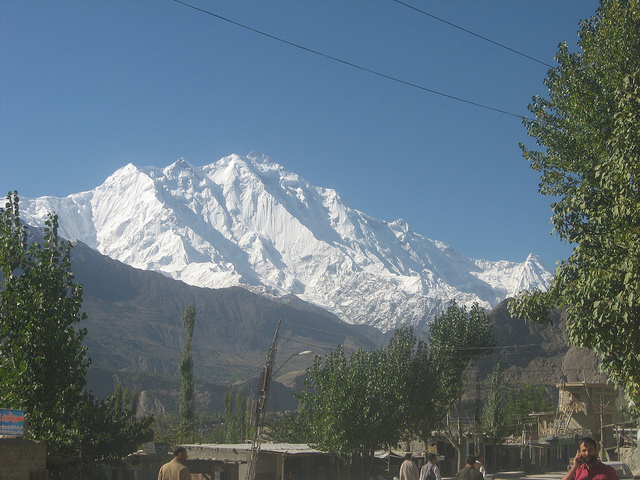<image>What kind of trees are these? I am not sure. The trees can be of different types like oak, evergreen, maple or elm. What kind of trees are these? I don't know what kind of trees these are. It can be seen 'oak', 'evergreen', 'deciduous', 'maple', 'elm', or 'fruit'. 